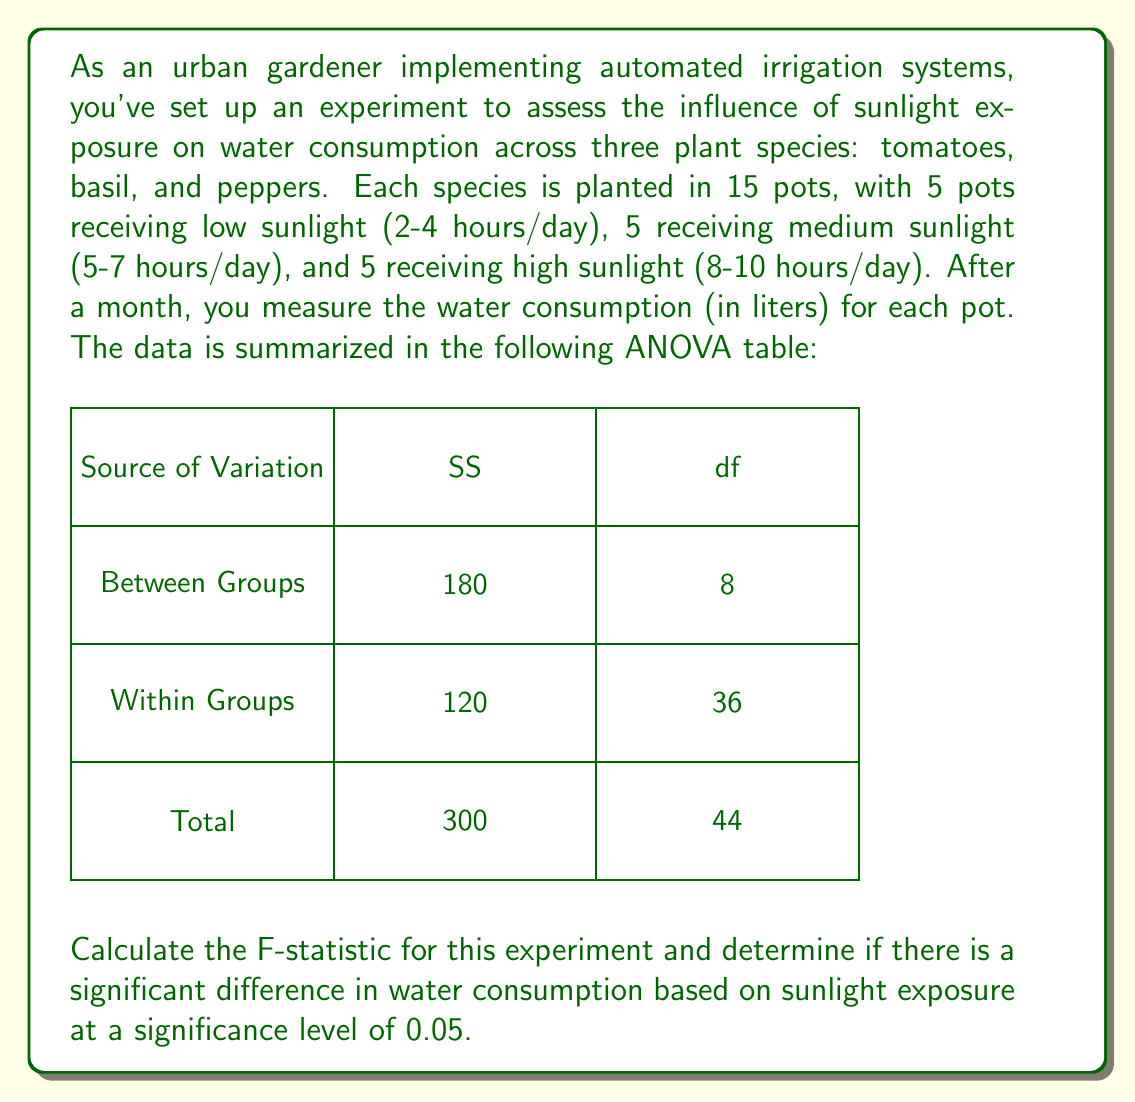Can you answer this question? To solve this problem, we'll follow these steps:

1) First, let's calculate the Mean Square (MS) for between groups and within groups:

   MS (Between) = SS (Between) / df (Between)
   $$ MS_{Between} = \frac{180}{8} = 22.5 $$

   MS (Within) = SS (Within) / df (Within)
   $$ MS_{Within} = \frac{120}{36} = 3.33 $$

2) The F-statistic is calculated as:

   $$ F = \frac{MS_{Between}}{MS_{Within}} = \frac{22.5}{3.33} = 6.76 $$

3) To determine if this F-value is significant, we need to compare it to the critical F-value. 
   For a significance level of 0.05, with df1 = 8 (between groups) and df2 = 36 (within groups), 
   the critical F-value is approximately 2.21 (this can be found in an F-distribution table).

4) Since our calculated F-value (6.76) is greater than the critical F-value (2.21), we can conclude 
   that there is a significant difference in water consumption based on sunlight exposure.

5) The p-value for this F-statistic would be less than 0.05, confirming the significance of the result.
Answer: F = 6.76, p < 0.05, significant difference 